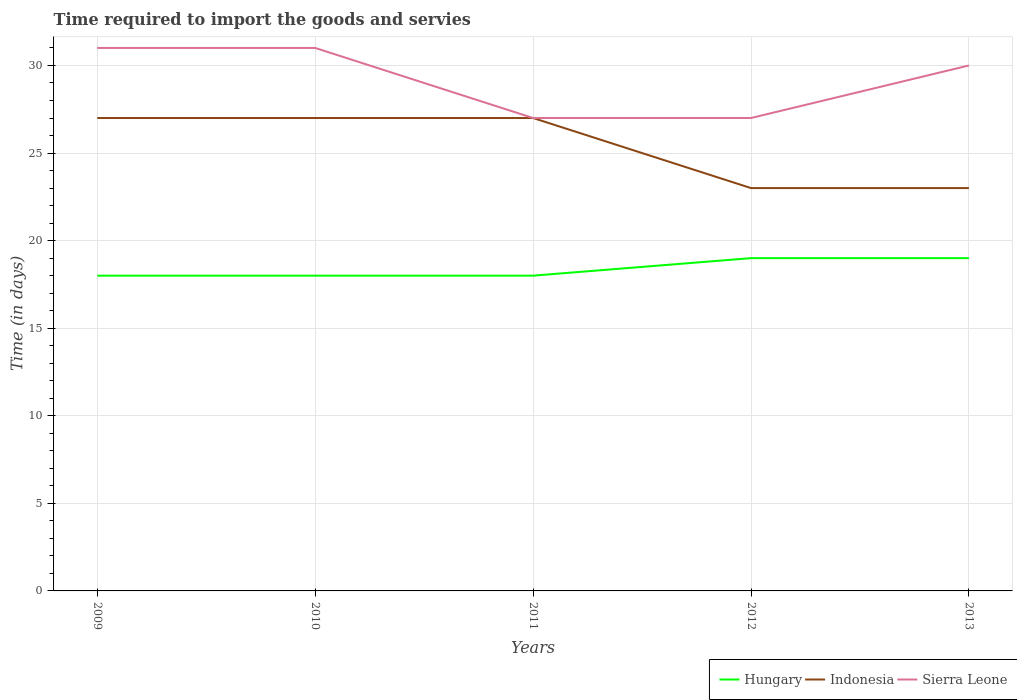Across all years, what is the maximum number of days required to import the goods and services in Sierra Leone?
Ensure brevity in your answer.  27. In which year was the number of days required to import the goods and services in Sierra Leone maximum?
Make the answer very short. 2011. What is the total number of days required to import the goods and services in Sierra Leone in the graph?
Keep it short and to the point. 1. What is the difference between the highest and the second highest number of days required to import the goods and services in Indonesia?
Your answer should be compact. 4. What is the difference between the highest and the lowest number of days required to import the goods and services in Hungary?
Offer a very short reply. 2. Is the number of days required to import the goods and services in Hungary strictly greater than the number of days required to import the goods and services in Sierra Leone over the years?
Keep it short and to the point. Yes. What is the difference between two consecutive major ticks on the Y-axis?
Make the answer very short. 5. Does the graph contain any zero values?
Provide a succinct answer. No. Does the graph contain grids?
Offer a very short reply. Yes. Where does the legend appear in the graph?
Ensure brevity in your answer.  Bottom right. How many legend labels are there?
Your answer should be compact. 3. How are the legend labels stacked?
Give a very brief answer. Horizontal. What is the title of the graph?
Offer a very short reply. Time required to import the goods and servies. What is the label or title of the X-axis?
Give a very brief answer. Years. What is the label or title of the Y-axis?
Your answer should be very brief. Time (in days). What is the Time (in days) of Indonesia in 2009?
Your response must be concise. 27. What is the Time (in days) in Sierra Leone in 2009?
Provide a succinct answer. 31. What is the Time (in days) of Hungary in 2010?
Ensure brevity in your answer.  18. What is the Time (in days) in Indonesia in 2010?
Your response must be concise. 27. What is the Time (in days) in Indonesia in 2012?
Your response must be concise. 23. What is the Time (in days) of Sierra Leone in 2012?
Provide a short and direct response. 27. What is the Time (in days) of Hungary in 2013?
Ensure brevity in your answer.  19. Across all years, what is the maximum Time (in days) in Indonesia?
Provide a succinct answer. 27. Across all years, what is the minimum Time (in days) of Hungary?
Your answer should be compact. 18. Across all years, what is the minimum Time (in days) in Indonesia?
Provide a short and direct response. 23. What is the total Time (in days) of Hungary in the graph?
Your answer should be very brief. 92. What is the total Time (in days) in Indonesia in the graph?
Your response must be concise. 127. What is the total Time (in days) in Sierra Leone in the graph?
Keep it short and to the point. 146. What is the difference between the Time (in days) in Hungary in 2009 and that in 2010?
Offer a very short reply. 0. What is the difference between the Time (in days) of Hungary in 2009 and that in 2011?
Ensure brevity in your answer.  0. What is the difference between the Time (in days) in Sierra Leone in 2009 and that in 2011?
Your answer should be compact. 4. What is the difference between the Time (in days) of Hungary in 2009 and that in 2012?
Your answer should be compact. -1. What is the difference between the Time (in days) of Sierra Leone in 2009 and that in 2013?
Make the answer very short. 1. What is the difference between the Time (in days) in Hungary in 2010 and that in 2011?
Offer a terse response. 0. What is the difference between the Time (in days) in Indonesia in 2010 and that in 2012?
Ensure brevity in your answer.  4. What is the difference between the Time (in days) in Sierra Leone in 2010 and that in 2012?
Your response must be concise. 4. What is the difference between the Time (in days) of Hungary in 2010 and that in 2013?
Offer a very short reply. -1. What is the difference between the Time (in days) in Sierra Leone in 2010 and that in 2013?
Offer a very short reply. 1. What is the difference between the Time (in days) of Indonesia in 2011 and that in 2013?
Provide a short and direct response. 4. What is the difference between the Time (in days) in Sierra Leone in 2011 and that in 2013?
Make the answer very short. -3. What is the difference between the Time (in days) of Indonesia in 2012 and that in 2013?
Offer a terse response. 0. What is the difference between the Time (in days) of Sierra Leone in 2012 and that in 2013?
Offer a very short reply. -3. What is the difference between the Time (in days) in Hungary in 2009 and the Time (in days) in Indonesia in 2010?
Keep it short and to the point. -9. What is the difference between the Time (in days) of Hungary in 2009 and the Time (in days) of Indonesia in 2011?
Your answer should be very brief. -9. What is the difference between the Time (in days) in Hungary in 2009 and the Time (in days) in Indonesia in 2012?
Provide a short and direct response. -5. What is the difference between the Time (in days) in Hungary in 2009 and the Time (in days) in Sierra Leone in 2012?
Make the answer very short. -9. What is the difference between the Time (in days) in Hungary in 2009 and the Time (in days) in Indonesia in 2013?
Keep it short and to the point. -5. What is the difference between the Time (in days) of Indonesia in 2009 and the Time (in days) of Sierra Leone in 2013?
Provide a short and direct response. -3. What is the difference between the Time (in days) in Indonesia in 2010 and the Time (in days) in Sierra Leone in 2011?
Your response must be concise. 0. What is the difference between the Time (in days) of Hungary in 2010 and the Time (in days) of Sierra Leone in 2012?
Your answer should be very brief. -9. What is the difference between the Time (in days) of Indonesia in 2010 and the Time (in days) of Sierra Leone in 2012?
Make the answer very short. 0. What is the difference between the Time (in days) of Hungary in 2010 and the Time (in days) of Indonesia in 2013?
Offer a terse response. -5. What is the difference between the Time (in days) of Hungary in 2011 and the Time (in days) of Indonesia in 2013?
Give a very brief answer. -5. What is the difference between the Time (in days) in Indonesia in 2011 and the Time (in days) in Sierra Leone in 2013?
Ensure brevity in your answer.  -3. What is the difference between the Time (in days) of Hungary in 2012 and the Time (in days) of Indonesia in 2013?
Your response must be concise. -4. What is the average Time (in days) in Hungary per year?
Your response must be concise. 18.4. What is the average Time (in days) in Indonesia per year?
Keep it short and to the point. 25.4. What is the average Time (in days) of Sierra Leone per year?
Make the answer very short. 29.2. In the year 2009, what is the difference between the Time (in days) of Hungary and Time (in days) of Indonesia?
Your response must be concise. -9. In the year 2010, what is the difference between the Time (in days) in Hungary and Time (in days) in Sierra Leone?
Keep it short and to the point. -13. In the year 2011, what is the difference between the Time (in days) of Hungary and Time (in days) of Indonesia?
Keep it short and to the point. -9. In the year 2011, what is the difference between the Time (in days) in Hungary and Time (in days) in Sierra Leone?
Ensure brevity in your answer.  -9. In the year 2012, what is the difference between the Time (in days) of Hungary and Time (in days) of Indonesia?
Your answer should be very brief. -4. In the year 2012, what is the difference between the Time (in days) of Hungary and Time (in days) of Sierra Leone?
Keep it short and to the point. -8. In the year 2013, what is the difference between the Time (in days) of Hungary and Time (in days) of Indonesia?
Keep it short and to the point. -4. What is the ratio of the Time (in days) of Hungary in 2009 to that in 2010?
Your answer should be compact. 1. What is the ratio of the Time (in days) of Indonesia in 2009 to that in 2010?
Your answer should be very brief. 1. What is the ratio of the Time (in days) in Sierra Leone in 2009 to that in 2010?
Ensure brevity in your answer.  1. What is the ratio of the Time (in days) in Indonesia in 2009 to that in 2011?
Offer a very short reply. 1. What is the ratio of the Time (in days) of Sierra Leone in 2009 to that in 2011?
Your answer should be compact. 1.15. What is the ratio of the Time (in days) in Indonesia in 2009 to that in 2012?
Provide a succinct answer. 1.17. What is the ratio of the Time (in days) of Sierra Leone in 2009 to that in 2012?
Your response must be concise. 1.15. What is the ratio of the Time (in days) of Indonesia in 2009 to that in 2013?
Provide a succinct answer. 1.17. What is the ratio of the Time (in days) in Sierra Leone in 2009 to that in 2013?
Ensure brevity in your answer.  1.03. What is the ratio of the Time (in days) of Hungary in 2010 to that in 2011?
Offer a terse response. 1. What is the ratio of the Time (in days) of Sierra Leone in 2010 to that in 2011?
Offer a very short reply. 1.15. What is the ratio of the Time (in days) in Indonesia in 2010 to that in 2012?
Provide a succinct answer. 1.17. What is the ratio of the Time (in days) in Sierra Leone in 2010 to that in 2012?
Provide a short and direct response. 1.15. What is the ratio of the Time (in days) in Hungary in 2010 to that in 2013?
Your answer should be compact. 0.95. What is the ratio of the Time (in days) of Indonesia in 2010 to that in 2013?
Offer a very short reply. 1.17. What is the ratio of the Time (in days) of Sierra Leone in 2010 to that in 2013?
Keep it short and to the point. 1.03. What is the ratio of the Time (in days) in Hungary in 2011 to that in 2012?
Offer a terse response. 0.95. What is the ratio of the Time (in days) in Indonesia in 2011 to that in 2012?
Give a very brief answer. 1.17. What is the ratio of the Time (in days) of Sierra Leone in 2011 to that in 2012?
Give a very brief answer. 1. What is the ratio of the Time (in days) in Hungary in 2011 to that in 2013?
Provide a succinct answer. 0.95. What is the ratio of the Time (in days) in Indonesia in 2011 to that in 2013?
Offer a very short reply. 1.17. What is the ratio of the Time (in days) in Hungary in 2012 to that in 2013?
Keep it short and to the point. 1. What is the difference between the highest and the second highest Time (in days) of Hungary?
Your answer should be very brief. 0. What is the difference between the highest and the lowest Time (in days) in Indonesia?
Your answer should be very brief. 4. 